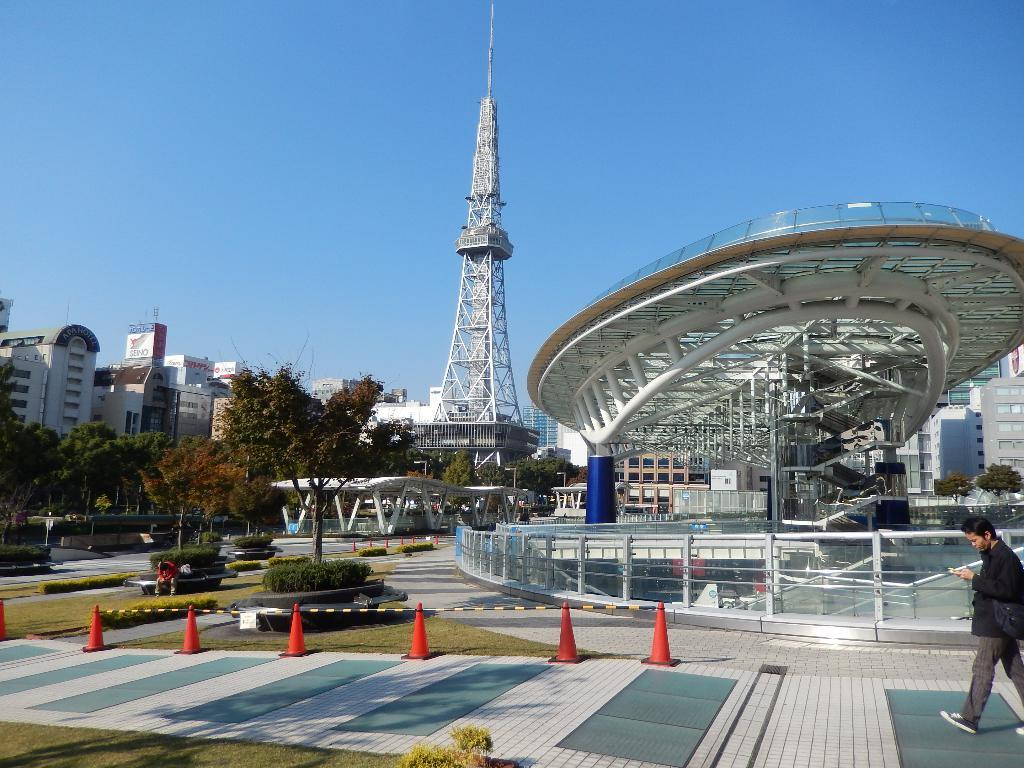What is the main structure in the image? There is a tower in the image. What can be seen in the sky in the image? The sky is visible in the image. What type of vegetation is present in the image? There are trees, bushes, and shrubs visible in the image. What type of ground cover is present in the image? Grass is present in the image. What type of man-made structures can be seen in the image? There are buildings, name boards, and poles visible in the image. What is the person in the image doing? There is a person walking on the road in the image. What safety equipment is visible in the image? Traffic cones are visible in the image. How many children are playing with the shape sorter in the image? There are no children or shape sorter present in the image. 